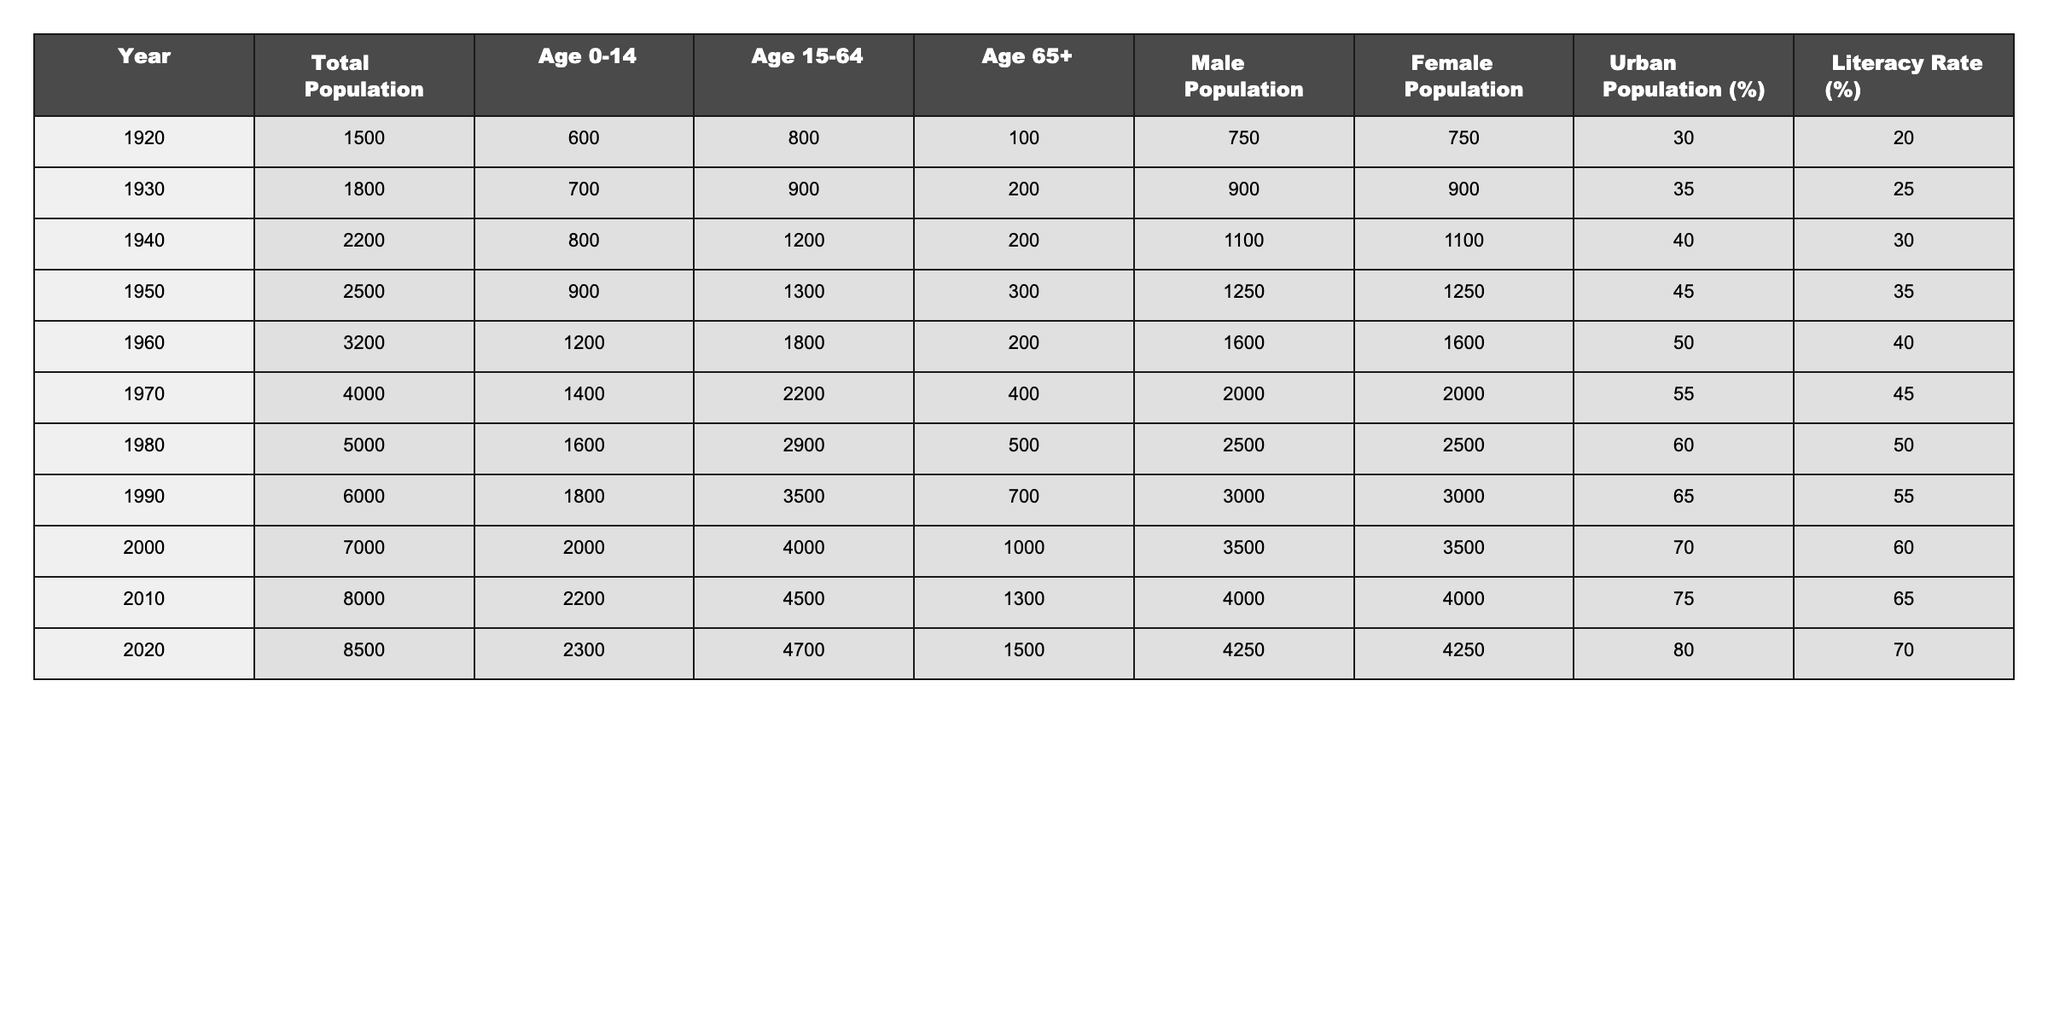What was the total population in 1950? The table shows the total population for each year. In 1950, the total population was listed as 2500.
Answer: 2500 What percentage of the population was aged 0-14 in 1980? The table indicates that in 1980, the population aged 0-14 was 1600. To find the percentage, we calculate (1600 / 5000) * 100 = 32%.
Answer: 32% What is the difference in literacy rates between 1920 and 2020? The literacy rate in 1920 was 20%, and in 2020 it was 70%. The difference is 70% - 20% = 50%.
Answer: 50% Which year recorded the highest male population, and what was that number? By examining the male population across the years, 2010 shows the highest male population at 4000.
Answer: 4000 What was the ratio of the elderly population (Age 65+) to the total population in 2000? In 2000, the elderly population was 1000 and the total population was 7000. The ratio is 1000/7000 = 1/7 or approximately 0.14.
Answer: 1/7 Did the urban population percentage ever exceed 75% in the years listed? Looking through the urban population percentages, the maximum recorded was 80% in 2020, so yes, it did exceed 75%.
Answer: Yes What trend can be observed in the total population from 1920 to 2020? The total population has consistently increased each decade, from 1500 in 1920 to 8500 in 2020, indicating a strong upward trend.
Answer: Strong upward trend In which decade did the age group 15-64 have the highest number of individuals? The age group 15-64 reached its peak in 2020 with a count of 4700.
Answer: 2020 What was the average literacy rate from 1920 to 2020? We sum the literacy rates for all years: (20 + 25 + 30 + 35 + 40 + 45 + 50 + 55 + 60 + 65 + 70 =  600), and divide by 11 years, giving us an average of 54.55%.
Answer: Approximately 54.55% What was the change in total population from 1970 to 1980? The total population in 1970 was 4000 and in 1980 it was 5000, so the change is 5000 - 4000 = 1000.
Answer: 1000 